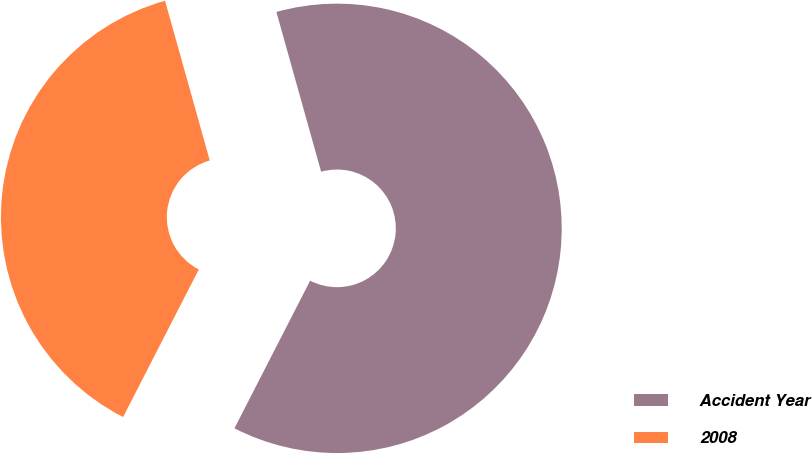Convert chart. <chart><loc_0><loc_0><loc_500><loc_500><pie_chart><fcel>Accident Year<fcel>2008<nl><fcel>61.89%<fcel>38.11%<nl></chart> 